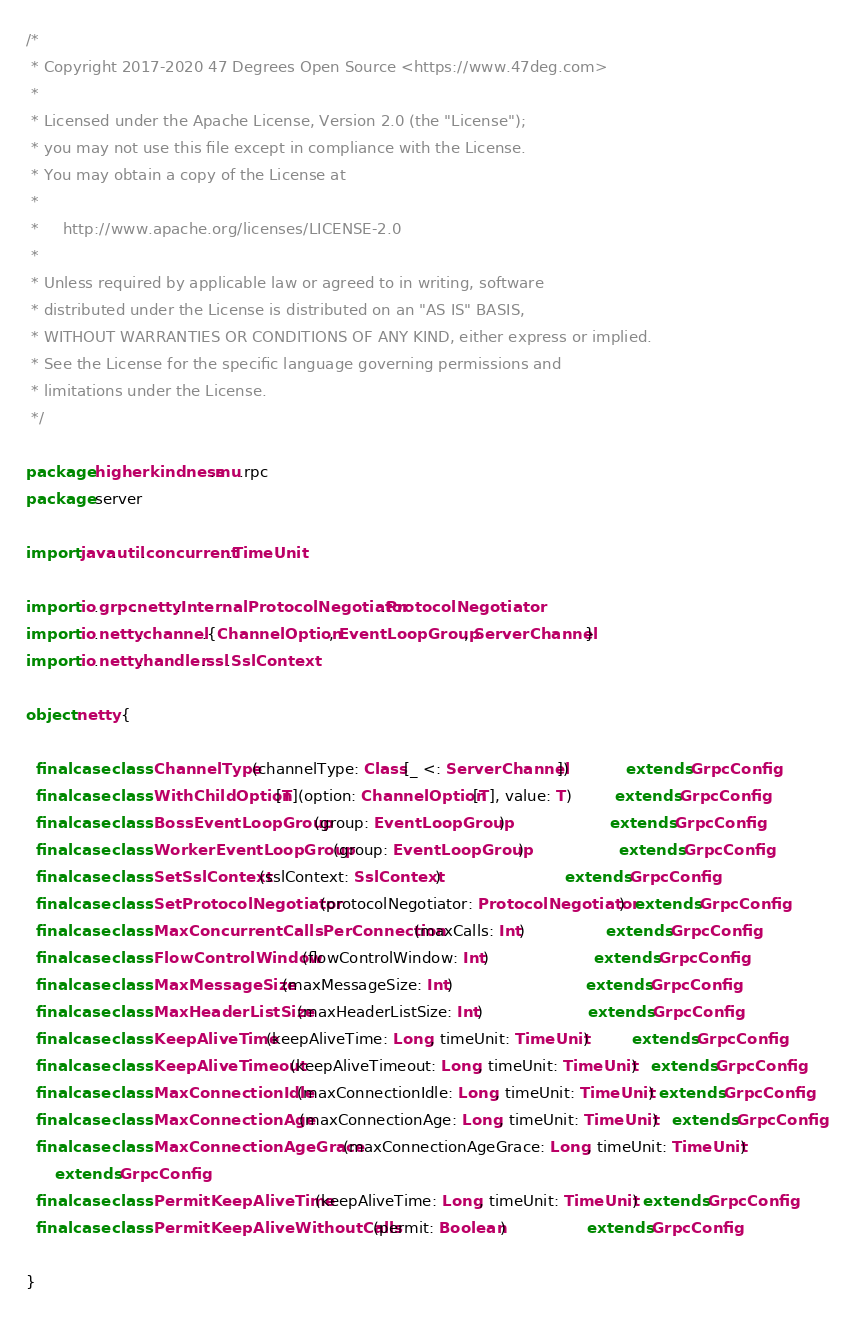Convert code to text. <code><loc_0><loc_0><loc_500><loc_500><_Scala_>/*
 * Copyright 2017-2020 47 Degrees Open Source <https://www.47deg.com>
 *
 * Licensed under the Apache License, Version 2.0 (the "License");
 * you may not use this file except in compliance with the License.
 * You may obtain a copy of the License at
 *
 *     http://www.apache.org/licenses/LICENSE-2.0
 *
 * Unless required by applicable law or agreed to in writing, software
 * distributed under the License is distributed on an "AS IS" BASIS,
 * WITHOUT WARRANTIES OR CONDITIONS OF ANY KIND, either express or implied.
 * See the License for the specific language governing permissions and
 * limitations under the License.
 */

package higherkindness.mu.rpc
package server

import java.util.concurrent.TimeUnit

import io.grpc.netty.InternalProtocolNegotiator.ProtocolNegotiator
import io.netty.channel.{ChannelOption, EventLoopGroup, ServerChannel}
import io.netty.handler.ssl.SslContext

object netty {

  final case class ChannelType(channelType: Class[_ <: ServerChannel])            extends GrpcConfig
  final case class WithChildOption[T](option: ChannelOption[T], value: T)         extends GrpcConfig
  final case class BossEventLoopGroup(group: EventLoopGroup)                      extends GrpcConfig
  final case class WorkerEventLoopGroup(group: EventLoopGroup)                    extends GrpcConfig
  final case class SetSslContext(sslContext: SslContext)                          extends GrpcConfig
  final case class SetProtocolNegotiator(protocolNegotiator: ProtocolNegotiator)  extends GrpcConfig
  final case class MaxConcurrentCallsPerConnection(maxCalls: Int)                 extends GrpcConfig
  final case class FlowControlWindow(flowControlWindow: Int)                      extends GrpcConfig
  final case class MaxMessageSize(maxMessageSize: Int)                            extends GrpcConfig
  final case class MaxHeaderListSize(maxHeaderListSize: Int)                      extends GrpcConfig
  final case class KeepAliveTime(keepAliveTime: Long, timeUnit: TimeUnit)         extends GrpcConfig
  final case class KeepAliveTimeout(keepAliveTimeout: Long, timeUnit: TimeUnit)   extends GrpcConfig
  final case class MaxConnectionIdle(maxConnectionIdle: Long, timeUnit: TimeUnit) extends GrpcConfig
  final case class MaxConnectionAge(maxConnectionAge: Long, timeUnit: TimeUnit)   extends GrpcConfig
  final case class MaxConnectionAgeGrace(maxConnectionAgeGrace: Long, timeUnit: TimeUnit)
      extends GrpcConfig
  final case class PermitKeepAliveTime(keepAliveTime: Long, timeUnit: TimeUnit) extends GrpcConfig
  final case class PermitKeepAliveWithoutCalls(permit: Boolean)                 extends GrpcConfig

}
</code> 